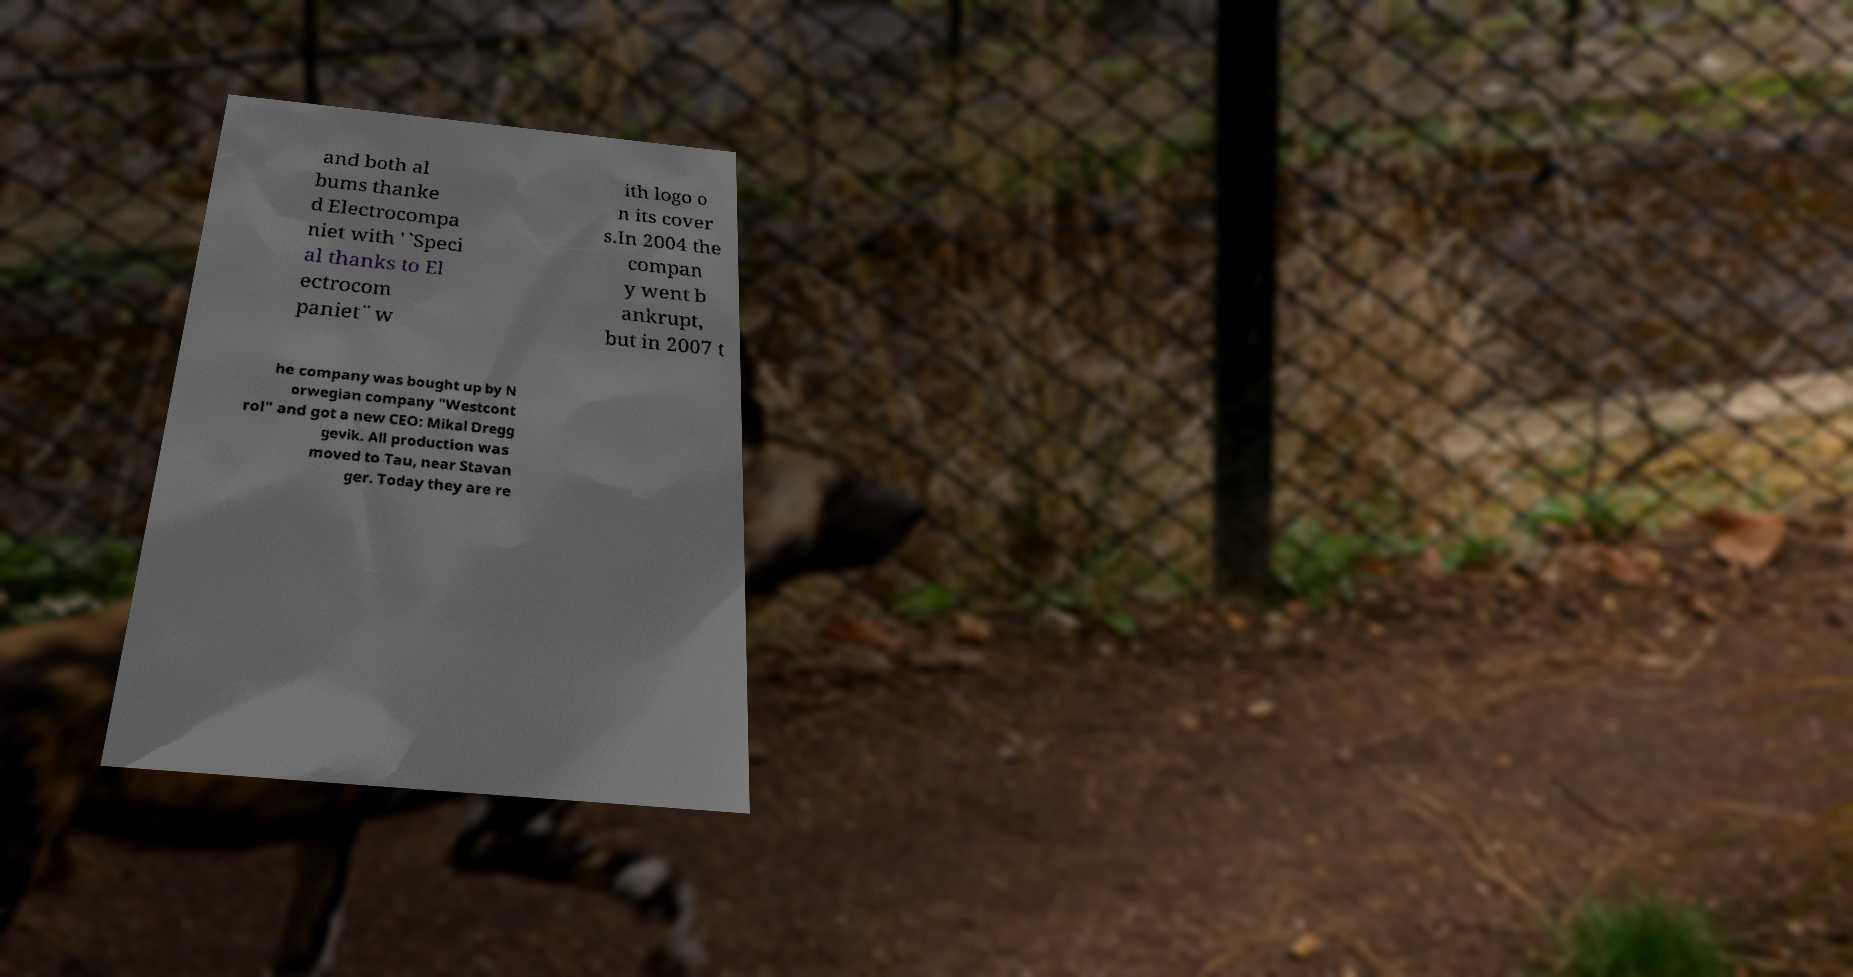What messages or text are displayed in this image? I need them in a readable, typed format. and both al bums thanke d Electrocompa niet with '`Speci al thanks to El ectrocom paniet¨ w ith logo o n its cover s.In 2004 the compan y went b ankrupt, but in 2007 t he company was bought up by N orwegian company "Westcont rol" and got a new CEO: Mikal Dregg gevik. All production was moved to Tau, near Stavan ger. Today they are re 